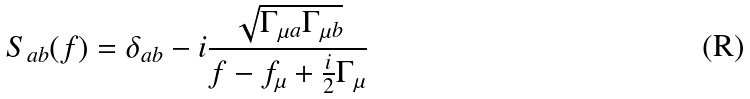<formula> <loc_0><loc_0><loc_500><loc_500>S _ { a b } ( f ) = \delta _ { a b } - i \frac { \sqrt { \Gamma _ { \mu a } \Gamma _ { \mu b } } } { f - f _ { \mu } + \frac { i } { 2 } \Gamma _ { \mu } } \,</formula> 